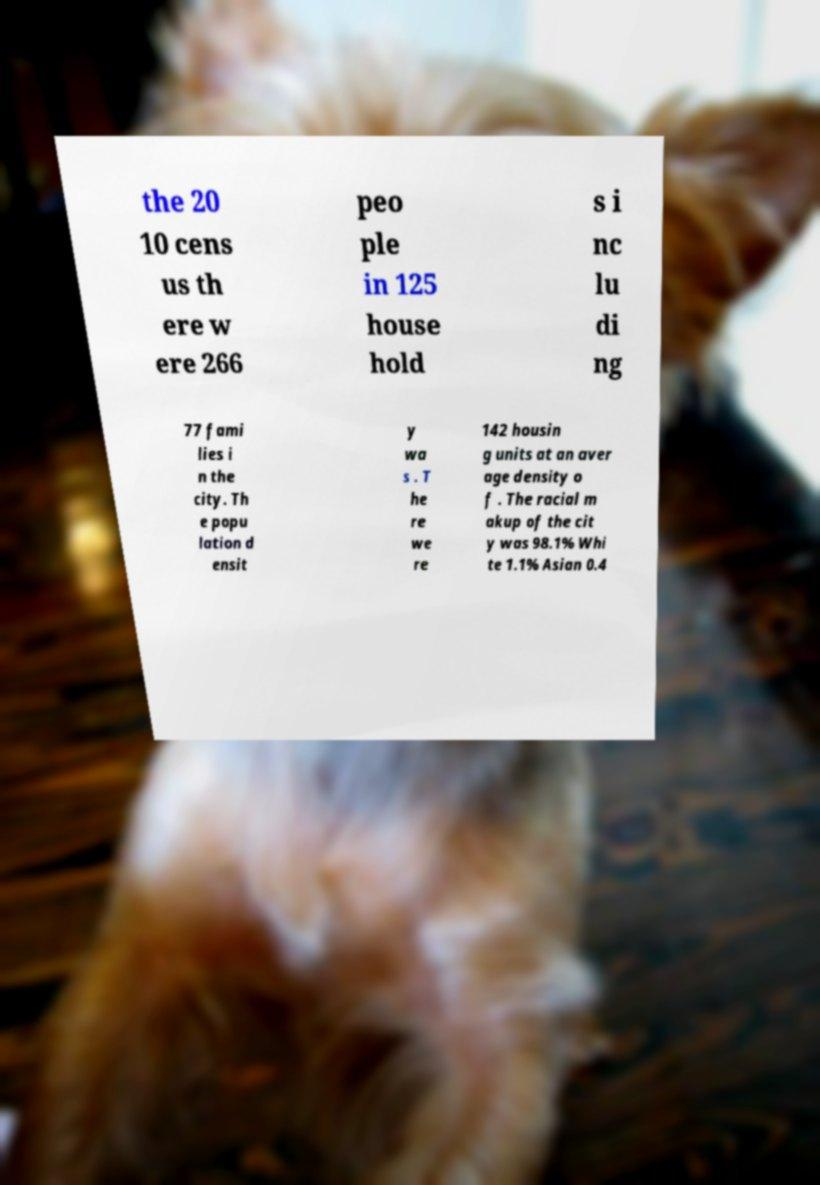Please identify and transcribe the text found in this image. the 20 10 cens us th ere w ere 266 peo ple in 125 house hold s i nc lu di ng 77 fami lies i n the city. Th e popu lation d ensit y wa s . T he re we re 142 housin g units at an aver age density o f . The racial m akup of the cit y was 98.1% Whi te 1.1% Asian 0.4 